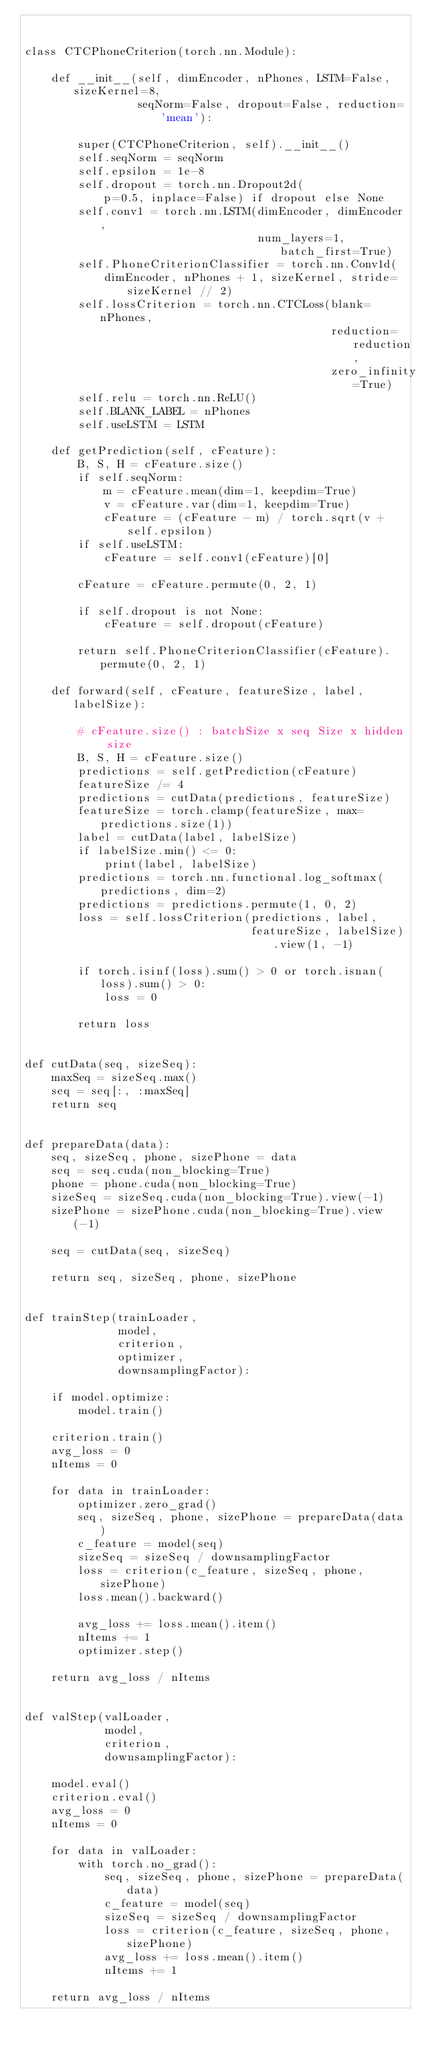<code> <loc_0><loc_0><loc_500><loc_500><_Python_>

class CTCPhoneCriterion(torch.nn.Module):

    def __init__(self, dimEncoder, nPhones, LSTM=False, sizeKernel=8,
                 seqNorm=False, dropout=False, reduction='mean'):

        super(CTCPhoneCriterion, self).__init__()
        self.seqNorm = seqNorm
        self.epsilon = 1e-8
        self.dropout = torch.nn.Dropout2d(
            p=0.5, inplace=False) if dropout else None
        self.conv1 = torch.nn.LSTM(dimEncoder, dimEncoder,
                                   num_layers=1, batch_first=True)
        self.PhoneCriterionClassifier = torch.nn.Conv1d(
            dimEncoder, nPhones + 1, sizeKernel, stride=sizeKernel // 2)
        self.lossCriterion = torch.nn.CTCLoss(blank=nPhones,
                                              reduction=reduction,
                                              zero_infinity=True)
        self.relu = torch.nn.ReLU()
        self.BLANK_LABEL = nPhones
        self.useLSTM = LSTM

    def getPrediction(self, cFeature):
        B, S, H = cFeature.size()
        if self.seqNorm:
            m = cFeature.mean(dim=1, keepdim=True)
            v = cFeature.var(dim=1, keepdim=True)
            cFeature = (cFeature - m) / torch.sqrt(v + self.epsilon)
        if self.useLSTM:
            cFeature = self.conv1(cFeature)[0]

        cFeature = cFeature.permute(0, 2, 1)

        if self.dropout is not None:
            cFeature = self.dropout(cFeature)

        return self.PhoneCriterionClassifier(cFeature).permute(0, 2, 1)

    def forward(self, cFeature, featureSize, label, labelSize):

        # cFeature.size() : batchSize x seq Size x hidden size
        B, S, H = cFeature.size()
        predictions = self.getPrediction(cFeature)
        featureSize /= 4
        predictions = cutData(predictions, featureSize)
        featureSize = torch.clamp(featureSize, max=predictions.size(1))
        label = cutData(label, labelSize)
        if labelSize.min() <= 0:
            print(label, labelSize)
        predictions = torch.nn.functional.log_softmax(predictions, dim=2)
        predictions = predictions.permute(1, 0, 2)
        loss = self.lossCriterion(predictions, label,
                                  featureSize, labelSize).view(1, -1)

        if torch.isinf(loss).sum() > 0 or torch.isnan(loss).sum() > 0:
            loss = 0

        return loss


def cutData(seq, sizeSeq):
    maxSeq = sizeSeq.max()
    seq = seq[:, :maxSeq]
    return seq


def prepareData(data):
    seq, sizeSeq, phone, sizePhone = data
    seq = seq.cuda(non_blocking=True)
    phone = phone.cuda(non_blocking=True)
    sizeSeq = sizeSeq.cuda(non_blocking=True).view(-1)
    sizePhone = sizePhone.cuda(non_blocking=True).view(-1)

    seq = cutData(seq, sizeSeq)

    return seq, sizeSeq, phone, sizePhone


def trainStep(trainLoader,
              model,
              criterion,
              optimizer,
              downsamplingFactor):

    if model.optimize:
        model.train()

    criterion.train()
    avg_loss = 0
    nItems = 0

    for data in trainLoader:
        optimizer.zero_grad()
        seq, sizeSeq, phone, sizePhone = prepareData(data)
        c_feature = model(seq)
        sizeSeq = sizeSeq / downsamplingFactor
        loss = criterion(c_feature, sizeSeq, phone, sizePhone)
        loss.mean().backward()

        avg_loss += loss.mean().item()
        nItems += 1
        optimizer.step()

    return avg_loss / nItems


def valStep(valLoader,
            model,
            criterion,
            downsamplingFactor):

    model.eval()
    criterion.eval()
    avg_loss = 0
    nItems = 0

    for data in valLoader:
        with torch.no_grad():
            seq, sizeSeq, phone, sizePhone = prepareData(data)
            c_feature = model(seq)
            sizeSeq = sizeSeq / downsamplingFactor
            loss = criterion(c_feature, sizeSeq, phone, sizePhone)
            avg_loss += loss.mean().item()
            nItems += 1

    return avg_loss / nItems
</code> 